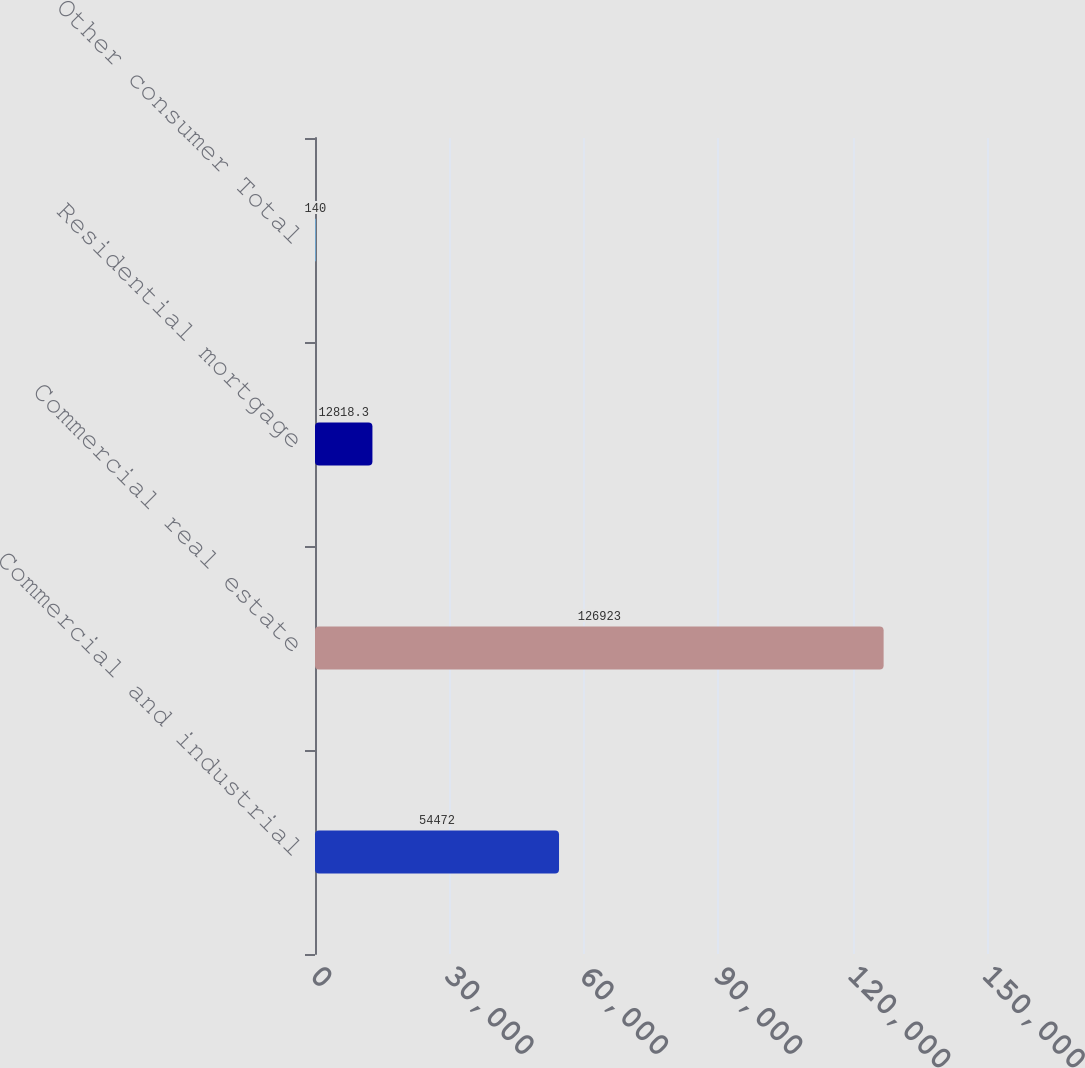Convert chart. <chart><loc_0><loc_0><loc_500><loc_500><bar_chart><fcel>Commercial and industrial<fcel>Commercial real estate<fcel>Residential mortgage<fcel>Other consumer Total<nl><fcel>54472<fcel>126923<fcel>12818.3<fcel>140<nl></chart> 